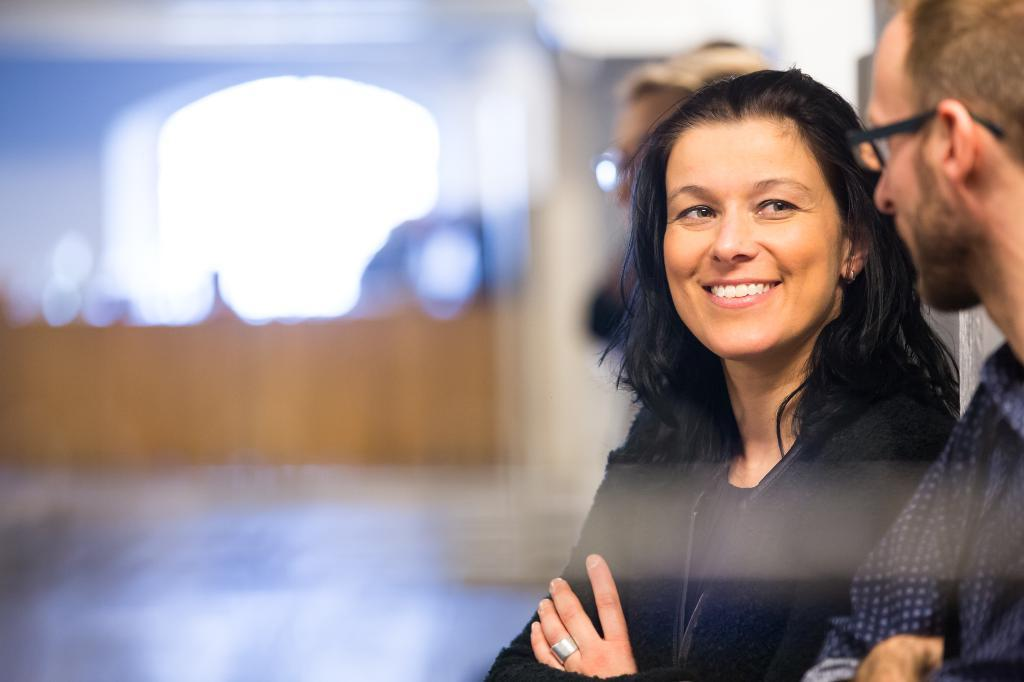How many people are present in the image? There are three people in the image: a man, a woman, and another person. What is the expression of the woman in the image? The woman is smiling in the image. Can you describe the background of the image? The background of the image is blurred. What type of beast can be seen in the image? There is no beast present in the image; it features three people and a blurred background. How many centimeters tall is the man in the image? The provided facts do not include information about the man's height, so it cannot be determined from the image. 